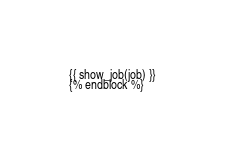Convert code to text. <code><loc_0><loc_0><loc_500><loc_500><_HTML_>{{ show_job(job) }}
{% endblock %}</code> 